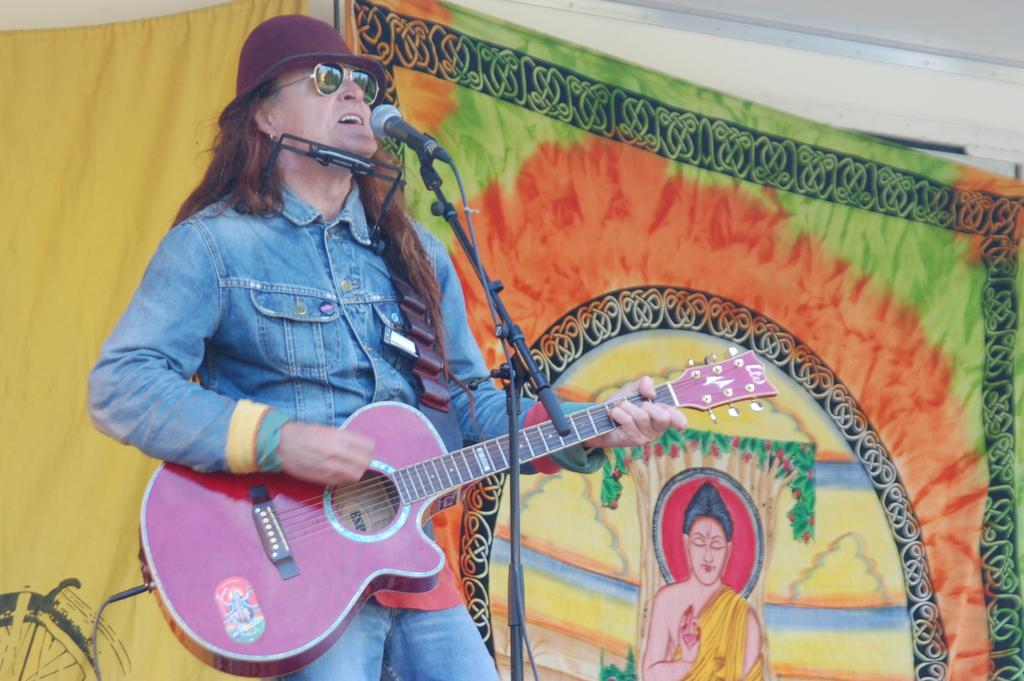What is the man in the image doing? The man is singing. What object is the man holding in the image? The man is holding a microphone. What musical instrument is the man playing in the image? The man is playing a guitar. What type of cracker is the man using to tune the guitar in the image? There is no cracker present in the image, and the man is not using any cracker to tune the guitar. Can you tell me how many needles are visible in the image? There are no needles visible in the image. 